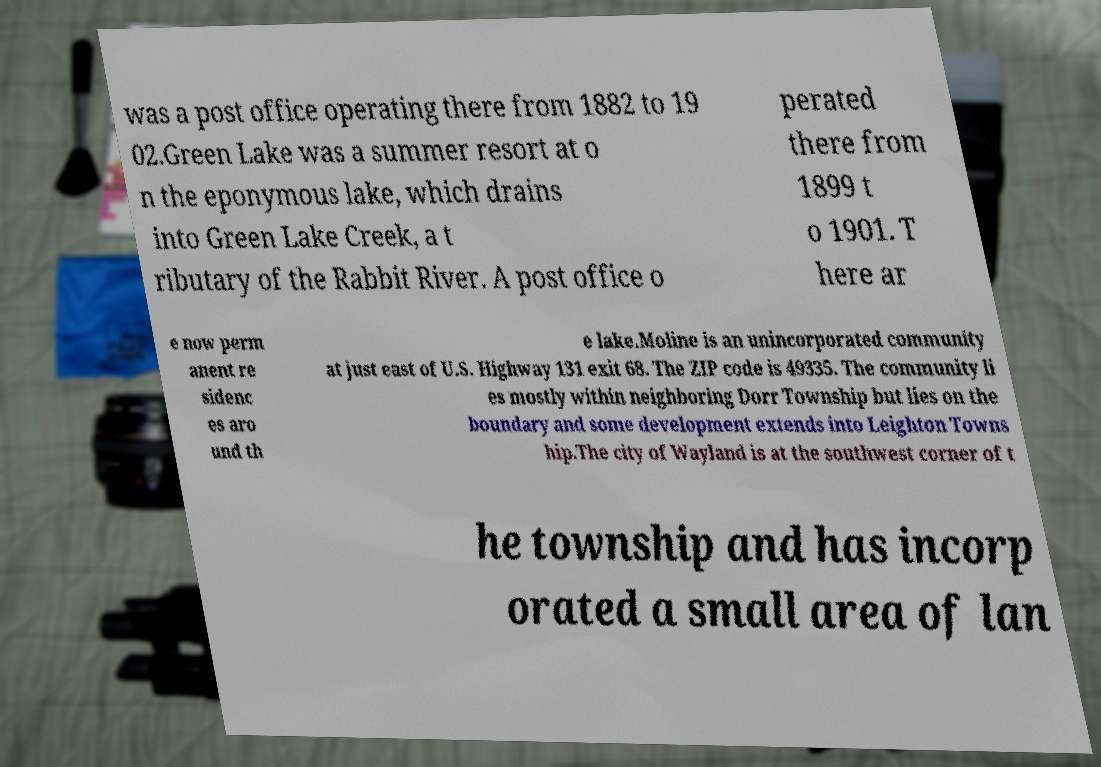Can you accurately transcribe the text from the provided image for me? was a post office operating there from 1882 to 19 02.Green Lake was a summer resort at o n the eponymous lake, which drains into Green Lake Creek, a t ributary of the Rabbit River. A post office o perated there from 1899 t o 1901. T here ar e now perm anent re sidenc es aro und th e lake.Moline is an unincorporated community at just east of U.S. Highway 131 exit 68. The ZIP code is 49335. The community li es mostly within neighboring Dorr Township but lies on the boundary and some development extends into Leighton Towns hip.The city of Wayland is at the southwest corner of t he township and has incorp orated a small area of lan 